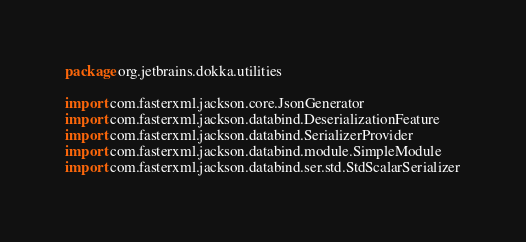<code> <loc_0><loc_0><loc_500><loc_500><_Kotlin_>package org.jetbrains.dokka.utilities

import com.fasterxml.jackson.core.JsonGenerator
import com.fasterxml.jackson.databind.DeserializationFeature
import com.fasterxml.jackson.databind.SerializerProvider
import com.fasterxml.jackson.databind.module.SimpleModule
import com.fasterxml.jackson.databind.ser.std.StdScalarSerializer</code> 